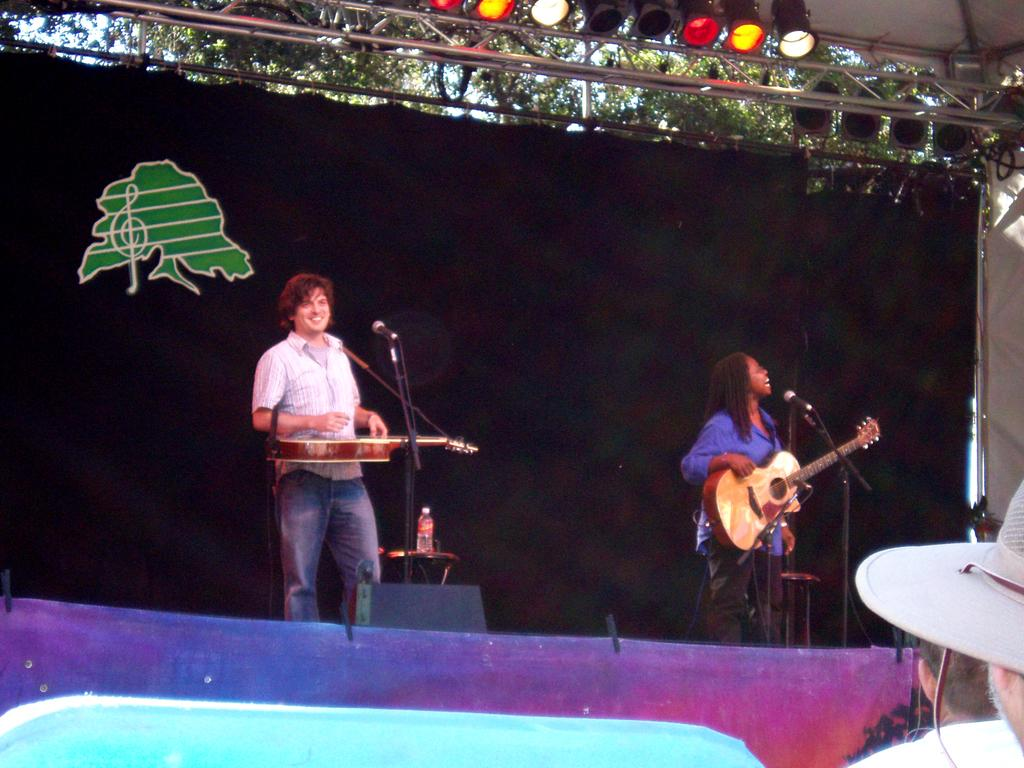How many people are in the image? There are two persons in the image. What are the persons doing in the image? The persons are playing guitar. What objects are in front of the persons? There are microphones in front of the persons. Where are the persons located in the image? The persons are standing on a stage. What can be seen at the top of the image? There are lights visible at the top of the image. How many beads are on the guitar strings in the image? There are no beads visible on the guitar strings in the image. What type of respect is being shown by the persons in the image? There is no indication of respect being shown in the image; the persons are simply playing guitar. 